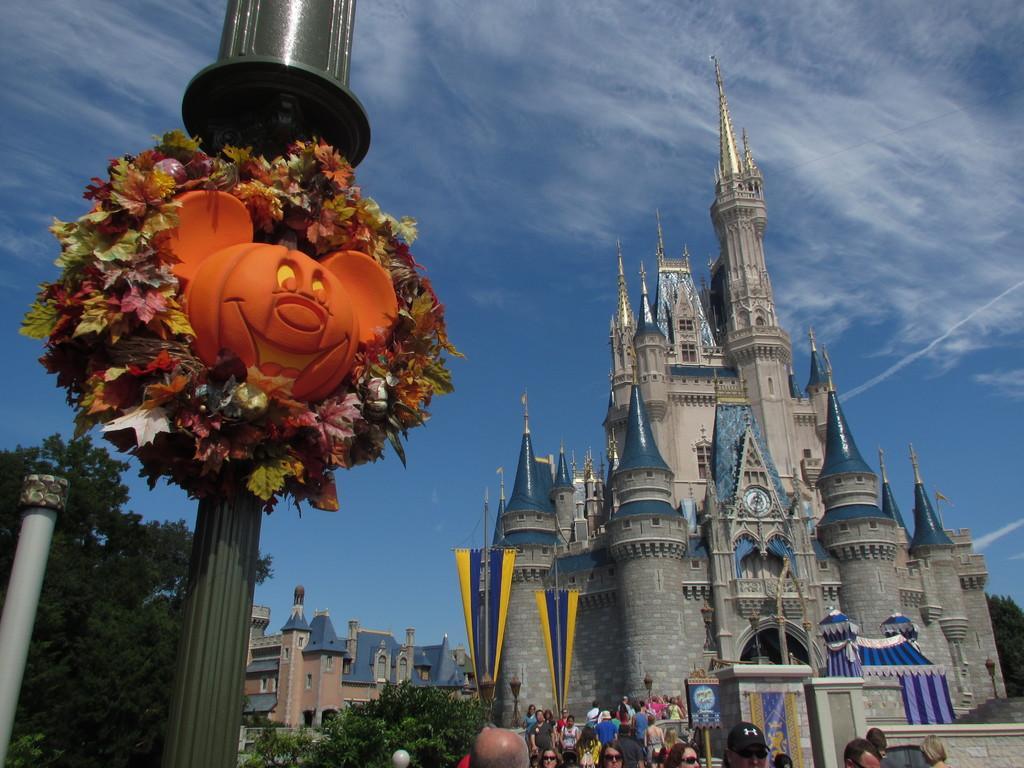How would you summarize this image in a sentence or two? On the left side there is a mickey mouse shape in orange color to the pole, at the bottom there are people are walking on this fort and on the left side there are trees. At the top there is the sky. 